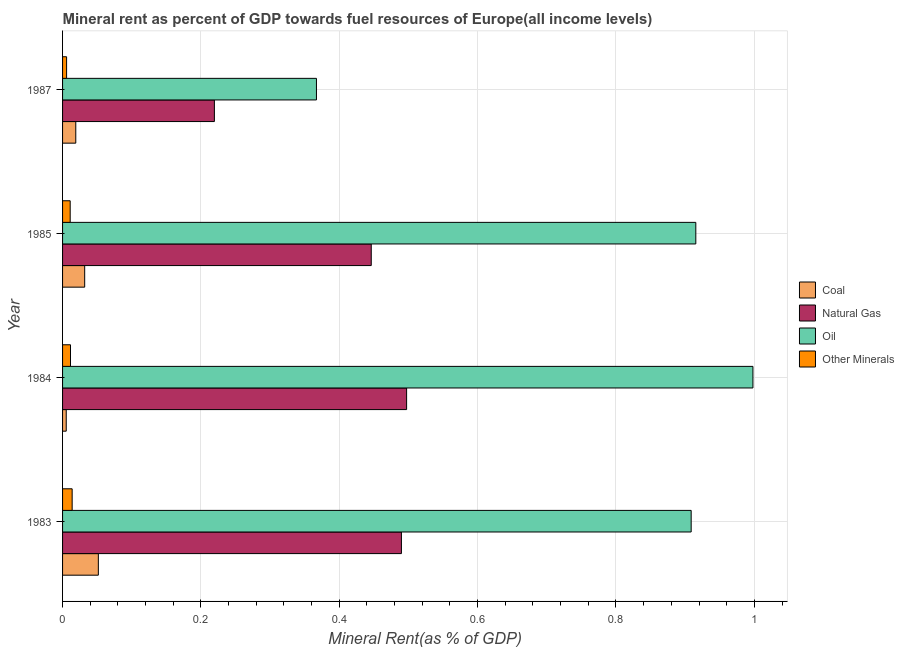How many different coloured bars are there?
Your answer should be very brief. 4. Are the number of bars per tick equal to the number of legend labels?
Provide a succinct answer. Yes. What is the label of the 4th group of bars from the top?
Make the answer very short. 1983. In how many cases, is the number of bars for a given year not equal to the number of legend labels?
Provide a short and direct response. 0. What is the  rent of other minerals in 1987?
Ensure brevity in your answer.  0.01. Across all years, what is the maximum natural gas rent?
Ensure brevity in your answer.  0.5. Across all years, what is the minimum coal rent?
Keep it short and to the point. 0.01. What is the total natural gas rent in the graph?
Give a very brief answer. 1.65. What is the difference between the  rent of other minerals in 1983 and that in 1987?
Provide a succinct answer. 0.01. What is the difference between the natural gas rent in 1985 and the oil rent in 1983?
Your response must be concise. -0.46. What is the average  rent of other minerals per year?
Your answer should be very brief. 0.01. In the year 1984, what is the difference between the coal rent and oil rent?
Your answer should be very brief. -0.99. In how many years, is the natural gas rent greater than 0.12 %?
Make the answer very short. 4. What is the ratio of the coal rent in 1983 to that in 1984?
Make the answer very short. 9.77. Is the  rent of other minerals in 1983 less than that in 1984?
Ensure brevity in your answer.  No. What is the difference between the highest and the second highest  rent of other minerals?
Your answer should be compact. 0. Is it the case that in every year, the sum of the natural gas rent and oil rent is greater than the sum of  rent of other minerals and coal rent?
Your response must be concise. No. What does the 4th bar from the top in 1983 represents?
Offer a terse response. Coal. What does the 3rd bar from the bottom in 1985 represents?
Your answer should be compact. Oil. Is it the case that in every year, the sum of the coal rent and natural gas rent is greater than the oil rent?
Offer a very short reply. No. Are all the bars in the graph horizontal?
Give a very brief answer. Yes. How many years are there in the graph?
Provide a succinct answer. 4. What is the difference between two consecutive major ticks on the X-axis?
Keep it short and to the point. 0.2. Are the values on the major ticks of X-axis written in scientific E-notation?
Offer a very short reply. No. Does the graph contain any zero values?
Your answer should be very brief. No. Does the graph contain grids?
Your response must be concise. Yes. How many legend labels are there?
Provide a short and direct response. 4. What is the title of the graph?
Your answer should be compact. Mineral rent as percent of GDP towards fuel resources of Europe(all income levels). Does "Greece" appear as one of the legend labels in the graph?
Keep it short and to the point. No. What is the label or title of the X-axis?
Your response must be concise. Mineral Rent(as % of GDP). What is the label or title of the Y-axis?
Provide a succinct answer. Year. What is the Mineral Rent(as % of GDP) in Coal in 1983?
Your response must be concise. 0.05. What is the Mineral Rent(as % of GDP) in Natural Gas in 1983?
Make the answer very short. 0.49. What is the Mineral Rent(as % of GDP) of Oil in 1983?
Offer a very short reply. 0.91. What is the Mineral Rent(as % of GDP) in Other Minerals in 1983?
Provide a short and direct response. 0.01. What is the Mineral Rent(as % of GDP) in Coal in 1984?
Make the answer very short. 0.01. What is the Mineral Rent(as % of GDP) in Natural Gas in 1984?
Ensure brevity in your answer.  0.5. What is the Mineral Rent(as % of GDP) in Oil in 1984?
Provide a succinct answer. 1. What is the Mineral Rent(as % of GDP) of Other Minerals in 1984?
Provide a short and direct response. 0.01. What is the Mineral Rent(as % of GDP) in Coal in 1985?
Ensure brevity in your answer.  0.03. What is the Mineral Rent(as % of GDP) in Natural Gas in 1985?
Provide a succinct answer. 0.45. What is the Mineral Rent(as % of GDP) in Oil in 1985?
Provide a succinct answer. 0.92. What is the Mineral Rent(as % of GDP) of Other Minerals in 1985?
Make the answer very short. 0.01. What is the Mineral Rent(as % of GDP) in Coal in 1987?
Provide a succinct answer. 0.02. What is the Mineral Rent(as % of GDP) of Natural Gas in 1987?
Provide a succinct answer. 0.22. What is the Mineral Rent(as % of GDP) in Oil in 1987?
Your response must be concise. 0.37. What is the Mineral Rent(as % of GDP) of Other Minerals in 1987?
Your response must be concise. 0.01. Across all years, what is the maximum Mineral Rent(as % of GDP) of Coal?
Your response must be concise. 0.05. Across all years, what is the maximum Mineral Rent(as % of GDP) in Natural Gas?
Give a very brief answer. 0.5. Across all years, what is the maximum Mineral Rent(as % of GDP) in Oil?
Provide a succinct answer. 1. Across all years, what is the maximum Mineral Rent(as % of GDP) in Other Minerals?
Offer a very short reply. 0.01. Across all years, what is the minimum Mineral Rent(as % of GDP) in Coal?
Offer a very short reply. 0.01. Across all years, what is the minimum Mineral Rent(as % of GDP) of Natural Gas?
Offer a terse response. 0.22. Across all years, what is the minimum Mineral Rent(as % of GDP) in Oil?
Ensure brevity in your answer.  0.37. Across all years, what is the minimum Mineral Rent(as % of GDP) of Other Minerals?
Your answer should be very brief. 0.01. What is the total Mineral Rent(as % of GDP) of Coal in the graph?
Ensure brevity in your answer.  0.11. What is the total Mineral Rent(as % of GDP) of Natural Gas in the graph?
Ensure brevity in your answer.  1.65. What is the total Mineral Rent(as % of GDP) in Oil in the graph?
Provide a short and direct response. 3.19. What is the total Mineral Rent(as % of GDP) in Other Minerals in the graph?
Keep it short and to the point. 0.04. What is the difference between the Mineral Rent(as % of GDP) in Coal in 1983 and that in 1984?
Your answer should be compact. 0.05. What is the difference between the Mineral Rent(as % of GDP) in Natural Gas in 1983 and that in 1984?
Provide a succinct answer. -0.01. What is the difference between the Mineral Rent(as % of GDP) in Oil in 1983 and that in 1984?
Offer a very short reply. -0.09. What is the difference between the Mineral Rent(as % of GDP) of Other Minerals in 1983 and that in 1984?
Offer a very short reply. 0. What is the difference between the Mineral Rent(as % of GDP) of Coal in 1983 and that in 1985?
Provide a succinct answer. 0.02. What is the difference between the Mineral Rent(as % of GDP) of Natural Gas in 1983 and that in 1985?
Offer a very short reply. 0.04. What is the difference between the Mineral Rent(as % of GDP) of Oil in 1983 and that in 1985?
Provide a succinct answer. -0.01. What is the difference between the Mineral Rent(as % of GDP) in Other Minerals in 1983 and that in 1985?
Make the answer very short. 0. What is the difference between the Mineral Rent(as % of GDP) of Coal in 1983 and that in 1987?
Provide a succinct answer. 0.03. What is the difference between the Mineral Rent(as % of GDP) in Natural Gas in 1983 and that in 1987?
Your answer should be compact. 0.27. What is the difference between the Mineral Rent(as % of GDP) in Oil in 1983 and that in 1987?
Provide a succinct answer. 0.54. What is the difference between the Mineral Rent(as % of GDP) in Other Minerals in 1983 and that in 1987?
Your response must be concise. 0.01. What is the difference between the Mineral Rent(as % of GDP) of Coal in 1984 and that in 1985?
Make the answer very short. -0.03. What is the difference between the Mineral Rent(as % of GDP) in Natural Gas in 1984 and that in 1985?
Provide a succinct answer. 0.05. What is the difference between the Mineral Rent(as % of GDP) in Oil in 1984 and that in 1985?
Offer a very short reply. 0.08. What is the difference between the Mineral Rent(as % of GDP) in Coal in 1984 and that in 1987?
Provide a short and direct response. -0.01. What is the difference between the Mineral Rent(as % of GDP) in Natural Gas in 1984 and that in 1987?
Give a very brief answer. 0.28. What is the difference between the Mineral Rent(as % of GDP) of Oil in 1984 and that in 1987?
Offer a very short reply. 0.63. What is the difference between the Mineral Rent(as % of GDP) in Other Minerals in 1984 and that in 1987?
Offer a very short reply. 0.01. What is the difference between the Mineral Rent(as % of GDP) in Coal in 1985 and that in 1987?
Keep it short and to the point. 0.01. What is the difference between the Mineral Rent(as % of GDP) of Natural Gas in 1985 and that in 1987?
Provide a short and direct response. 0.23. What is the difference between the Mineral Rent(as % of GDP) in Oil in 1985 and that in 1987?
Your answer should be very brief. 0.55. What is the difference between the Mineral Rent(as % of GDP) of Other Minerals in 1985 and that in 1987?
Keep it short and to the point. 0.01. What is the difference between the Mineral Rent(as % of GDP) of Coal in 1983 and the Mineral Rent(as % of GDP) of Natural Gas in 1984?
Make the answer very short. -0.45. What is the difference between the Mineral Rent(as % of GDP) in Coal in 1983 and the Mineral Rent(as % of GDP) in Oil in 1984?
Provide a short and direct response. -0.95. What is the difference between the Mineral Rent(as % of GDP) in Coal in 1983 and the Mineral Rent(as % of GDP) in Other Minerals in 1984?
Ensure brevity in your answer.  0.04. What is the difference between the Mineral Rent(as % of GDP) in Natural Gas in 1983 and the Mineral Rent(as % of GDP) in Oil in 1984?
Your answer should be very brief. -0.51. What is the difference between the Mineral Rent(as % of GDP) in Natural Gas in 1983 and the Mineral Rent(as % of GDP) in Other Minerals in 1984?
Your response must be concise. 0.48. What is the difference between the Mineral Rent(as % of GDP) of Oil in 1983 and the Mineral Rent(as % of GDP) of Other Minerals in 1984?
Make the answer very short. 0.9. What is the difference between the Mineral Rent(as % of GDP) of Coal in 1983 and the Mineral Rent(as % of GDP) of Natural Gas in 1985?
Give a very brief answer. -0.39. What is the difference between the Mineral Rent(as % of GDP) in Coal in 1983 and the Mineral Rent(as % of GDP) in Oil in 1985?
Ensure brevity in your answer.  -0.86. What is the difference between the Mineral Rent(as % of GDP) of Coal in 1983 and the Mineral Rent(as % of GDP) of Other Minerals in 1985?
Keep it short and to the point. 0.04. What is the difference between the Mineral Rent(as % of GDP) of Natural Gas in 1983 and the Mineral Rent(as % of GDP) of Oil in 1985?
Make the answer very short. -0.43. What is the difference between the Mineral Rent(as % of GDP) of Natural Gas in 1983 and the Mineral Rent(as % of GDP) of Other Minerals in 1985?
Ensure brevity in your answer.  0.48. What is the difference between the Mineral Rent(as % of GDP) in Oil in 1983 and the Mineral Rent(as % of GDP) in Other Minerals in 1985?
Your answer should be very brief. 0.9. What is the difference between the Mineral Rent(as % of GDP) of Coal in 1983 and the Mineral Rent(as % of GDP) of Natural Gas in 1987?
Your response must be concise. -0.17. What is the difference between the Mineral Rent(as % of GDP) of Coal in 1983 and the Mineral Rent(as % of GDP) of Oil in 1987?
Your answer should be compact. -0.32. What is the difference between the Mineral Rent(as % of GDP) of Coal in 1983 and the Mineral Rent(as % of GDP) of Other Minerals in 1987?
Give a very brief answer. 0.05. What is the difference between the Mineral Rent(as % of GDP) of Natural Gas in 1983 and the Mineral Rent(as % of GDP) of Oil in 1987?
Ensure brevity in your answer.  0.12. What is the difference between the Mineral Rent(as % of GDP) of Natural Gas in 1983 and the Mineral Rent(as % of GDP) of Other Minerals in 1987?
Offer a very short reply. 0.48. What is the difference between the Mineral Rent(as % of GDP) of Oil in 1983 and the Mineral Rent(as % of GDP) of Other Minerals in 1987?
Your answer should be very brief. 0.9. What is the difference between the Mineral Rent(as % of GDP) in Coal in 1984 and the Mineral Rent(as % of GDP) in Natural Gas in 1985?
Your answer should be compact. -0.44. What is the difference between the Mineral Rent(as % of GDP) of Coal in 1984 and the Mineral Rent(as % of GDP) of Oil in 1985?
Give a very brief answer. -0.91. What is the difference between the Mineral Rent(as % of GDP) of Coal in 1984 and the Mineral Rent(as % of GDP) of Other Minerals in 1985?
Offer a terse response. -0.01. What is the difference between the Mineral Rent(as % of GDP) in Natural Gas in 1984 and the Mineral Rent(as % of GDP) in Oil in 1985?
Provide a short and direct response. -0.42. What is the difference between the Mineral Rent(as % of GDP) in Natural Gas in 1984 and the Mineral Rent(as % of GDP) in Other Minerals in 1985?
Ensure brevity in your answer.  0.49. What is the difference between the Mineral Rent(as % of GDP) of Coal in 1984 and the Mineral Rent(as % of GDP) of Natural Gas in 1987?
Your response must be concise. -0.21. What is the difference between the Mineral Rent(as % of GDP) of Coal in 1984 and the Mineral Rent(as % of GDP) of Oil in 1987?
Provide a succinct answer. -0.36. What is the difference between the Mineral Rent(as % of GDP) of Coal in 1984 and the Mineral Rent(as % of GDP) of Other Minerals in 1987?
Ensure brevity in your answer.  -0. What is the difference between the Mineral Rent(as % of GDP) of Natural Gas in 1984 and the Mineral Rent(as % of GDP) of Oil in 1987?
Your answer should be compact. 0.13. What is the difference between the Mineral Rent(as % of GDP) in Natural Gas in 1984 and the Mineral Rent(as % of GDP) in Other Minerals in 1987?
Your answer should be very brief. 0.49. What is the difference between the Mineral Rent(as % of GDP) in Coal in 1985 and the Mineral Rent(as % of GDP) in Natural Gas in 1987?
Offer a terse response. -0.19. What is the difference between the Mineral Rent(as % of GDP) in Coal in 1985 and the Mineral Rent(as % of GDP) in Oil in 1987?
Your answer should be compact. -0.34. What is the difference between the Mineral Rent(as % of GDP) of Coal in 1985 and the Mineral Rent(as % of GDP) of Other Minerals in 1987?
Give a very brief answer. 0.03. What is the difference between the Mineral Rent(as % of GDP) of Natural Gas in 1985 and the Mineral Rent(as % of GDP) of Oil in 1987?
Your answer should be very brief. 0.08. What is the difference between the Mineral Rent(as % of GDP) of Natural Gas in 1985 and the Mineral Rent(as % of GDP) of Other Minerals in 1987?
Keep it short and to the point. 0.44. What is the difference between the Mineral Rent(as % of GDP) of Oil in 1985 and the Mineral Rent(as % of GDP) of Other Minerals in 1987?
Offer a very short reply. 0.91. What is the average Mineral Rent(as % of GDP) of Coal per year?
Keep it short and to the point. 0.03. What is the average Mineral Rent(as % of GDP) of Natural Gas per year?
Provide a short and direct response. 0.41. What is the average Mineral Rent(as % of GDP) in Oil per year?
Your answer should be very brief. 0.8. What is the average Mineral Rent(as % of GDP) in Other Minerals per year?
Make the answer very short. 0.01. In the year 1983, what is the difference between the Mineral Rent(as % of GDP) of Coal and Mineral Rent(as % of GDP) of Natural Gas?
Provide a succinct answer. -0.44. In the year 1983, what is the difference between the Mineral Rent(as % of GDP) in Coal and Mineral Rent(as % of GDP) in Oil?
Your response must be concise. -0.86. In the year 1983, what is the difference between the Mineral Rent(as % of GDP) in Coal and Mineral Rent(as % of GDP) in Other Minerals?
Make the answer very short. 0.04. In the year 1983, what is the difference between the Mineral Rent(as % of GDP) in Natural Gas and Mineral Rent(as % of GDP) in Oil?
Your answer should be compact. -0.42. In the year 1983, what is the difference between the Mineral Rent(as % of GDP) in Natural Gas and Mineral Rent(as % of GDP) in Other Minerals?
Ensure brevity in your answer.  0.48. In the year 1983, what is the difference between the Mineral Rent(as % of GDP) of Oil and Mineral Rent(as % of GDP) of Other Minerals?
Offer a very short reply. 0.89. In the year 1984, what is the difference between the Mineral Rent(as % of GDP) of Coal and Mineral Rent(as % of GDP) of Natural Gas?
Make the answer very short. -0.49. In the year 1984, what is the difference between the Mineral Rent(as % of GDP) in Coal and Mineral Rent(as % of GDP) in Oil?
Your response must be concise. -0.99. In the year 1984, what is the difference between the Mineral Rent(as % of GDP) in Coal and Mineral Rent(as % of GDP) in Other Minerals?
Make the answer very short. -0.01. In the year 1984, what is the difference between the Mineral Rent(as % of GDP) of Natural Gas and Mineral Rent(as % of GDP) of Oil?
Give a very brief answer. -0.5. In the year 1984, what is the difference between the Mineral Rent(as % of GDP) in Natural Gas and Mineral Rent(as % of GDP) in Other Minerals?
Provide a succinct answer. 0.49. In the year 1984, what is the difference between the Mineral Rent(as % of GDP) of Oil and Mineral Rent(as % of GDP) of Other Minerals?
Offer a very short reply. 0.99. In the year 1985, what is the difference between the Mineral Rent(as % of GDP) in Coal and Mineral Rent(as % of GDP) in Natural Gas?
Ensure brevity in your answer.  -0.41. In the year 1985, what is the difference between the Mineral Rent(as % of GDP) in Coal and Mineral Rent(as % of GDP) in Oil?
Ensure brevity in your answer.  -0.88. In the year 1985, what is the difference between the Mineral Rent(as % of GDP) of Coal and Mineral Rent(as % of GDP) of Other Minerals?
Offer a very short reply. 0.02. In the year 1985, what is the difference between the Mineral Rent(as % of GDP) of Natural Gas and Mineral Rent(as % of GDP) of Oil?
Offer a very short reply. -0.47. In the year 1985, what is the difference between the Mineral Rent(as % of GDP) in Natural Gas and Mineral Rent(as % of GDP) in Other Minerals?
Give a very brief answer. 0.44. In the year 1985, what is the difference between the Mineral Rent(as % of GDP) in Oil and Mineral Rent(as % of GDP) in Other Minerals?
Ensure brevity in your answer.  0.9. In the year 1987, what is the difference between the Mineral Rent(as % of GDP) of Coal and Mineral Rent(as % of GDP) of Natural Gas?
Offer a very short reply. -0.2. In the year 1987, what is the difference between the Mineral Rent(as % of GDP) in Coal and Mineral Rent(as % of GDP) in Oil?
Ensure brevity in your answer.  -0.35. In the year 1987, what is the difference between the Mineral Rent(as % of GDP) of Coal and Mineral Rent(as % of GDP) of Other Minerals?
Your response must be concise. 0.01. In the year 1987, what is the difference between the Mineral Rent(as % of GDP) in Natural Gas and Mineral Rent(as % of GDP) in Oil?
Ensure brevity in your answer.  -0.15. In the year 1987, what is the difference between the Mineral Rent(as % of GDP) of Natural Gas and Mineral Rent(as % of GDP) of Other Minerals?
Your response must be concise. 0.21. In the year 1987, what is the difference between the Mineral Rent(as % of GDP) in Oil and Mineral Rent(as % of GDP) in Other Minerals?
Keep it short and to the point. 0.36. What is the ratio of the Mineral Rent(as % of GDP) in Coal in 1983 to that in 1984?
Keep it short and to the point. 9.77. What is the ratio of the Mineral Rent(as % of GDP) in Natural Gas in 1983 to that in 1984?
Give a very brief answer. 0.98. What is the ratio of the Mineral Rent(as % of GDP) of Oil in 1983 to that in 1984?
Keep it short and to the point. 0.91. What is the ratio of the Mineral Rent(as % of GDP) in Other Minerals in 1983 to that in 1984?
Ensure brevity in your answer.  1.21. What is the ratio of the Mineral Rent(as % of GDP) of Coal in 1983 to that in 1985?
Provide a short and direct response. 1.62. What is the ratio of the Mineral Rent(as % of GDP) of Natural Gas in 1983 to that in 1985?
Provide a short and direct response. 1.1. What is the ratio of the Mineral Rent(as % of GDP) of Oil in 1983 to that in 1985?
Keep it short and to the point. 0.99. What is the ratio of the Mineral Rent(as % of GDP) in Other Minerals in 1983 to that in 1985?
Keep it short and to the point. 1.26. What is the ratio of the Mineral Rent(as % of GDP) of Coal in 1983 to that in 1987?
Provide a succinct answer. 2.71. What is the ratio of the Mineral Rent(as % of GDP) in Natural Gas in 1983 to that in 1987?
Make the answer very short. 2.23. What is the ratio of the Mineral Rent(as % of GDP) in Oil in 1983 to that in 1987?
Your response must be concise. 2.48. What is the ratio of the Mineral Rent(as % of GDP) of Other Minerals in 1983 to that in 1987?
Your answer should be compact. 2.38. What is the ratio of the Mineral Rent(as % of GDP) of Coal in 1984 to that in 1985?
Your answer should be compact. 0.17. What is the ratio of the Mineral Rent(as % of GDP) of Natural Gas in 1984 to that in 1985?
Your answer should be very brief. 1.11. What is the ratio of the Mineral Rent(as % of GDP) in Oil in 1984 to that in 1985?
Offer a terse response. 1.09. What is the ratio of the Mineral Rent(as % of GDP) in Other Minerals in 1984 to that in 1985?
Ensure brevity in your answer.  1.04. What is the ratio of the Mineral Rent(as % of GDP) in Coal in 1984 to that in 1987?
Your answer should be compact. 0.28. What is the ratio of the Mineral Rent(as % of GDP) in Natural Gas in 1984 to that in 1987?
Provide a short and direct response. 2.27. What is the ratio of the Mineral Rent(as % of GDP) in Oil in 1984 to that in 1987?
Your response must be concise. 2.72. What is the ratio of the Mineral Rent(as % of GDP) of Other Minerals in 1984 to that in 1987?
Your answer should be compact. 1.97. What is the ratio of the Mineral Rent(as % of GDP) in Coal in 1985 to that in 1987?
Offer a very short reply. 1.67. What is the ratio of the Mineral Rent(as % of GDP) in Natural Gas in 1985 to that in 1987?
Ensure brevity in your answer.  2.03. What is the ratio of the Mineral Rent(as % of GDP) in Oil in 1985 to that in 1987?
Give a very brief answer. 2.49. What is the ratio of the Mineral Rent(as % of GDP) in Other Minerals in 1985 to that in 1987?
Keep it short and to the point. 1.89. What is the difference between the highest and the second highest Mineral Rent(as % of GDP) in Coal?
Ensure brevity in your answer.  0.02. What is the difference between the highest and the second highest Mineral Rent(as % of GDP) of Natural Gas?
Offer a very short reply. 0.01. What is the difference between the highest and the second highest Mineral Rent(as % of GDP) of Oil?
Give a very brief answer. 0.08. What is the difference between the highest and the second highest Mineral Rent(as % of GDP) of Other Minerals?
Provide a short and direct response. 0. What is the difference between the highest and the lowest Mineral Rent(as % of GDP) in Coal?
Keep it short and to the point. 0.05. What is the difference between the highest and the lowest Mineral Rent(as % of GDP) in Natural Gas?
Provide a succinct answer. 0.28. What is the difference between the highest and the lowest Mineral Rent(as % of GDP) of Oil?
Your answer should be very brief. 0.63. What is the difference between the highest and the lowest Mineral Rent(as % of GDP) in Other Minerals?
Provide a succinct answer. 0.01. 